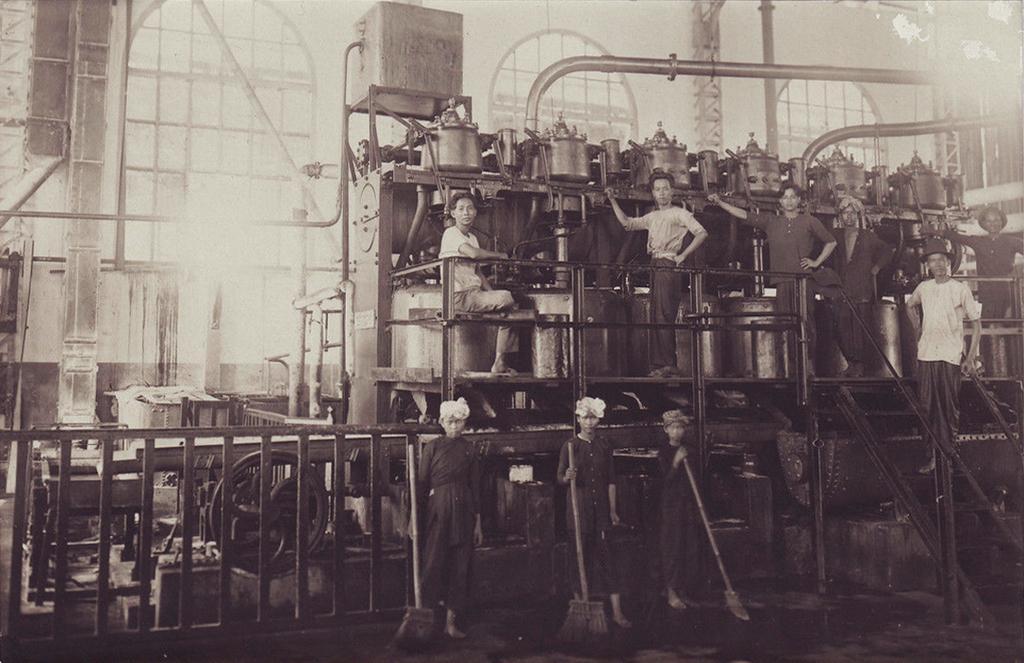Could you give a brief overview of what you see in this image? In this picture I can see the factory. I can see few people holding broomstick. I can see a few people standing I can see glass windows in the background. I can see stairs and railings. I can see a metal grill fence. 